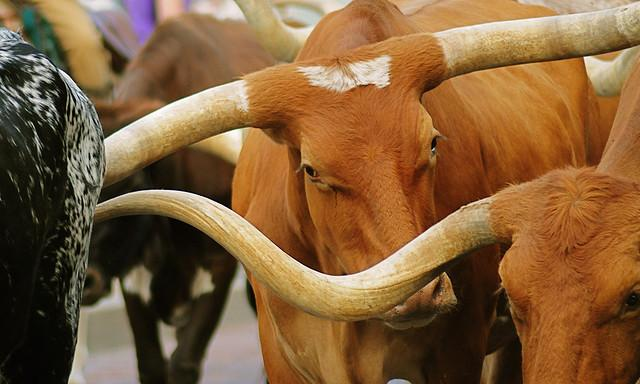What are long horn cows called?

Choices:
A) extended horn
B) horne
C) horner
D) longhorn cattle longhorn cattle 